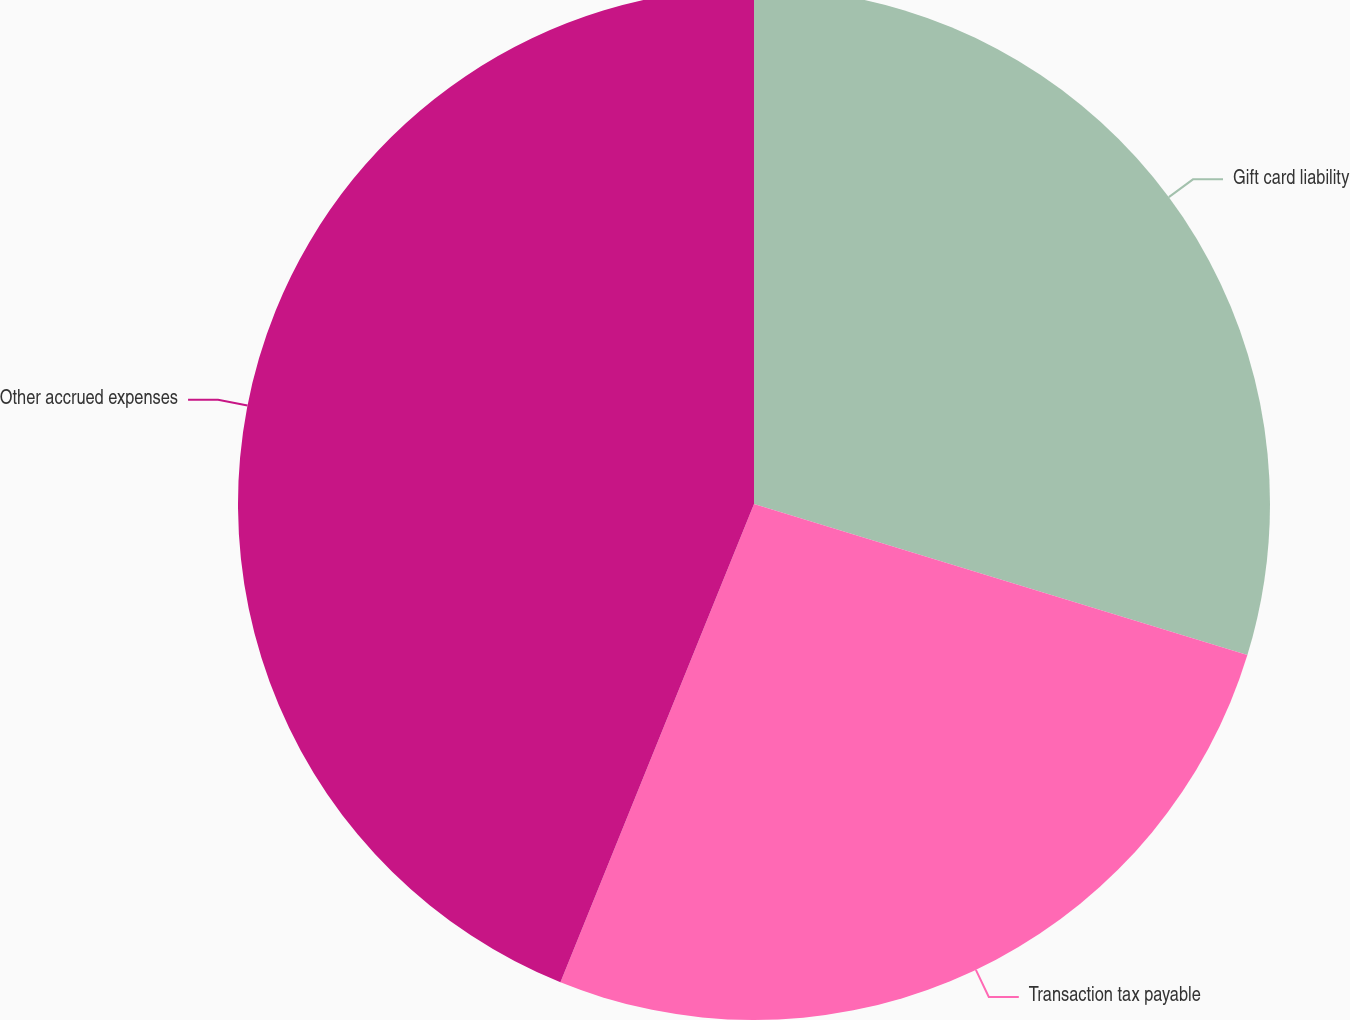Convert chart. <chart><loc_0><loc_0><loc_500><loc_500><pie_chart><fcel>Gift card liability<fcel>Transaction tax payable<fcel>Other accrued expenses<nl><fcel>29.73%<fcel>26.39%<fcel>43.88%<nl></chart> 